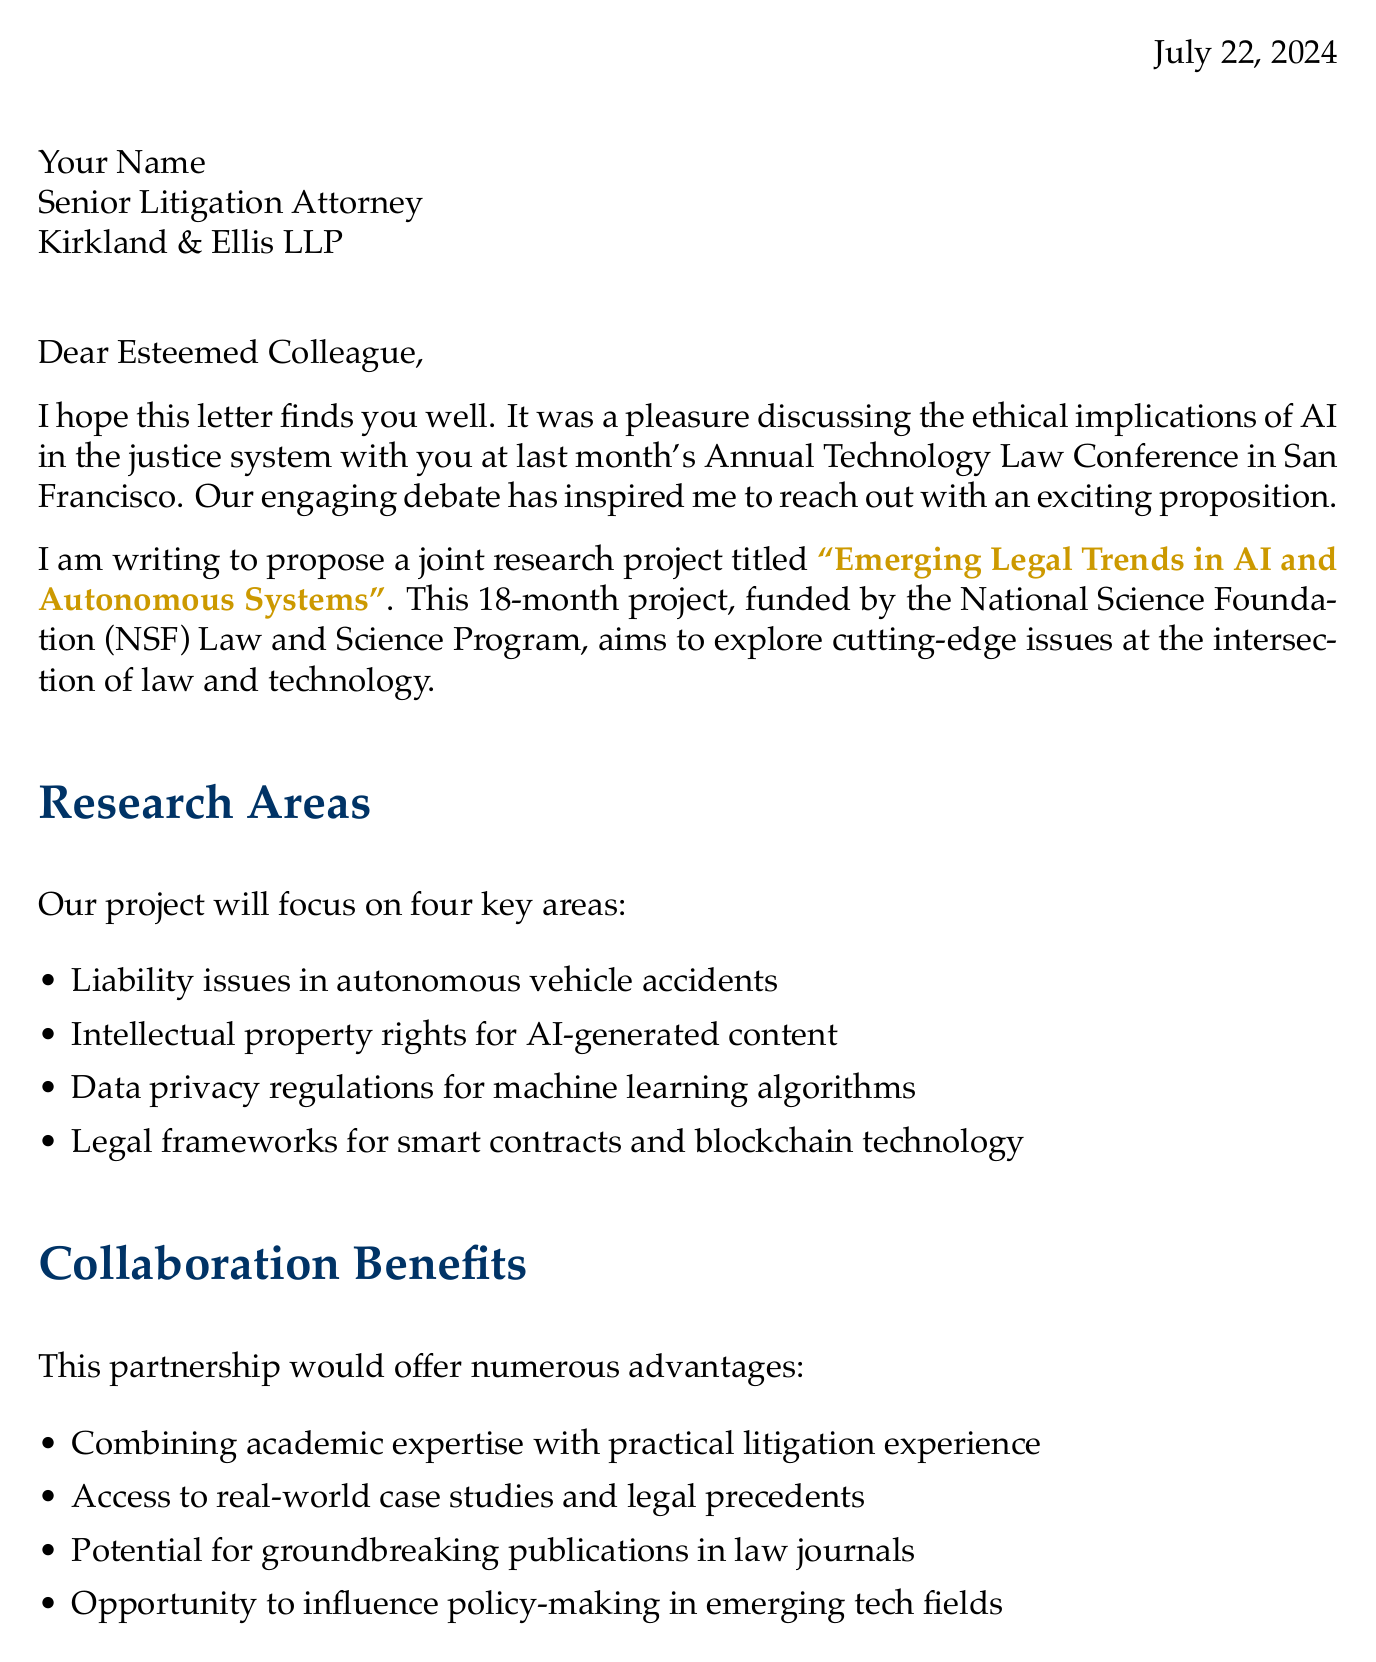What is the title of the proposed project? The title of the proposed project is specified in the project proposal section of the letter.
Answer: Emerging Legal Trends in AI and Autonomous Systems Who is the sender of the letter? The sender's details are outlined at the beginning of the letter, including name and title.
Answer: Dr. Alexandra Chen How long is the proposed project duration? The project duration is clearly stated in the project proposal section of the letter.
Answer: 18 months What is one anticipated outcome of the project? The letter lists expected outcomes in the corresponding section, allowing for a direct response.
Answer: Comprehensive report on the state of technology law When is the proposal submission deadline? The timeline for the project includes a specific date for proposal submission.
Answer: End of next month What is one benefit of collaboration mentioned in the letter? The collaboration benefits are listed, providing several examples of advantages.
Answer: Combining academic expertise with practical litigation experience Which organization is funding the project? The funding source is directly mentioned in the project proposal section.
Answer: National Science Foundation (NSF) Law and Science Program What area will be examined in the proposed research? The letter specifies key research areas, identifying topics of interest for the project.
Answer: Liability issues in autonomous vehicle accidents What request does Dr. Chen make at the end of the letter? The letter concludes with specific requests for input from the recipient.
Answer: Suggestions for additional research areas 